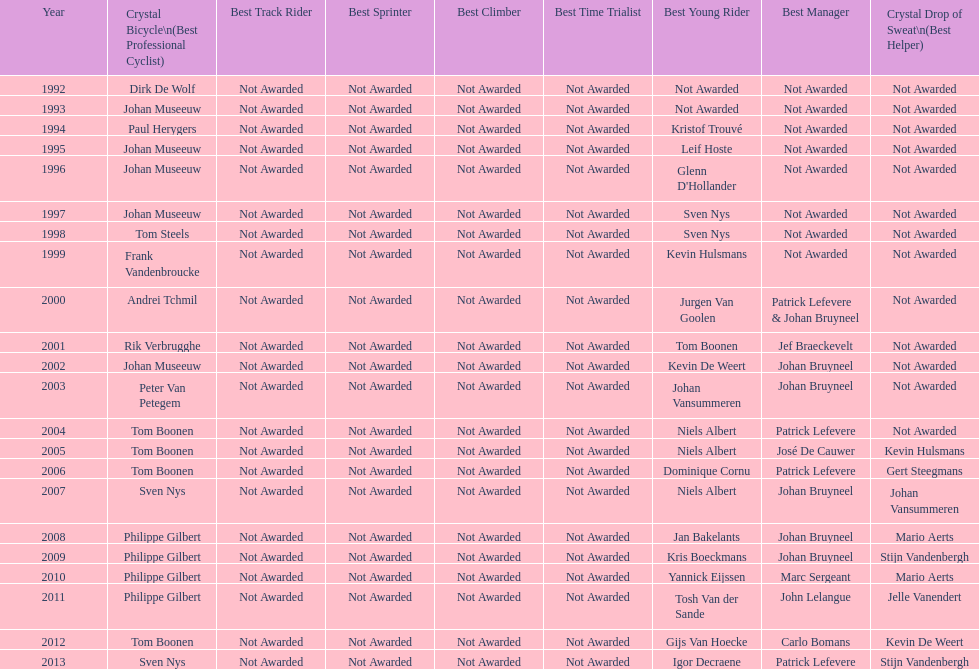On average, in how many instances was johan museeuw a star? 5. Would you be able to parse every entry in this table? {'header': ['Year', 'Crystal Bicycle\\n(Best Professional Cyclist)', 'Best Track Rider', 'Best Sprinter', 'Best Climber', 'Best Time Trialist', 'Best Young Rider', 'Best Manager', 'Crystal Drop of Sweat\\n(Best Helper)'], 'rows': [['1992', 'Dirk De Wolf', 'Not Awarded', 'Not Awarded', 'Not Awarded', 'Not Awarded', 'Not Awarded', 'Not Awarded', 'Not Awarded'], ['1993', 'Johan Museeuw', 'Not Awarded', 'Not Awarded', 'Not Awarded', 'Not Awarded', 'Not Awarded', 'Not Awarded', 'Not Awarded'], ['1994', 'Paul Herygers', 'Not Awarded', 'Not Awarded', 'Not Awarded', 'Not Awarded', 'Kristof Trouvé', 'Not Awarded', 'Not Awarded'], ['1995', 'Johan Museeuw', 'Not Awarded', 'Not Awarded', 'Not Awarded', 'Not Awarded', 'Leif Hoste', 'Not Awarded', 'Not Awarded'], ['1996', 'Johan Museeuw', 'Not Awarded', 'Not Awarded', 'Not Awarded', 'Not Awarded', "Glenn D'Hollander", 'Not Awarded', 'Not Awarded'], ['1997', 'Johan Museeuw', 'Not Awarded', 'Not Awarded', 'Not Awarded', 'Not Awarded', 'Sven Nys', 'Not Awarded', 'Not Awarded'], ['1998', 'Tom Steels', 'Not Awarded', 'Not Awarded', 'Not Awarded', 'Not Awarded', 'Sven Nys', 'Not Awarded', 'Not Awarded'], ['1999', 'Frank Vandenbroucke', 'Not Awarded', 'Not Awarded', 'Not Awarded', 'Not Awarded', 'Kevin Hulsmans', 'Not Awarded', 'Not Awarded'], ['2000', 'Andrei Tchmil', 'Not Awarded', 'Not Awarded', 'Not Awarded', 'Not Awarded', 'Jurgen Van Goolen', 'Patrick Lefevere & Johan Bruyneel', 'Not Awarded'], ['2001', 'Rik Verbrugghe', 'Not Awarded', 'Not Awarded', 'Not Awarded', 'Not Awarded', 'Tom Boonen', 'Jef Braeckevelt', 'Not Awarded'], ['2002', 'Johan Museeuw', 'Not Awarded', 'Not Awarded', 'Not Awarded', 'Not Awarded', 'Kevin De Weert', 'Johan Bruyneel', 'Not Awarded'], ['2003', 'Peter Van Petegem', 'Not Awarded', 'Not Awarded', 'Not Awarded', 'Not Awarded', 'Johan Vansummeren', 'Johan Bruyneel', 'Not Awarded'], ['2004', 'Tom Boonen', 'Not Awarded', 'Not Awarded', 'Not Awarded', 'Not Awarded', 'Niels Albert', 'Patrick Lefevere', 'Not Awarded'], ['2005', 'Tom Boonen', 'Not Awarded', 'Not Awarded', 'Not Awarded', 'Not Awarded', 'Niels Albert', 'José De Cauwer', 'Kevin Hulsmans'], ['2006', 'Tom Boonen', 'Not Awarded', 'Not Awarded', 'Not Awarded', 'Not Awarded', 'Dominique Cornu', 'Patrick Lefevere', 'Gert Steegmans'], ['2007', 'Sven Nys', 'Not Awarded', 'Not Awarded', 'Not Awarded', 'Not Awarded', 'Niels Albert', 'Johan Bruyneel', 'Johan Vansummeren'], ['2008', 'Philippe Gilbert', 'Not Awarded', 'Not Awarded', 'Not Awarded', 'Not Awarded', 'Jan Bakelants', 'Johan Bruyneel', 'Mario Aerts'], ['2009', 'Philippe Gilbert', 'Not Awarded', 'Not Awarded', 'Not Awarded', 'Not Awarded', 'Kris Boeckmans', 'Johan Bruyneel', 'Stijn Vandenbergh'], ['2010', 'Philippe Gilbert', 'Not Awarded', 'Not Awarded', 'Not Awarded', 'Not Awarded', 'Yannick Eijssen', 'Marc Sergeant', 'Mario Aerts'], ['2011', 'Philippe Gilbert', 'Not Awarded', 'Not Awarded', 'Not Awarded', 'Not Awarded', 'Tosh Van der Sande', 'John Lelangue', 'Jelle Vanendert'], ['2012', 'Tom Boonen', 'Not Awarded', 'Not Awarded', 'Not Awarded', 'Not Awarded', 'Gijs Van Hoecke', 'Carlo Bomans', 'Kevin De Weert'], ['2013', 'Sven Nys', 'Not Awarded', 'Not Awarded', 'Not Awarded', 'Not Awarded', 'Igor Decraene', 'Patrick Lefevere', 'Stijn Vandenbergh']]} 